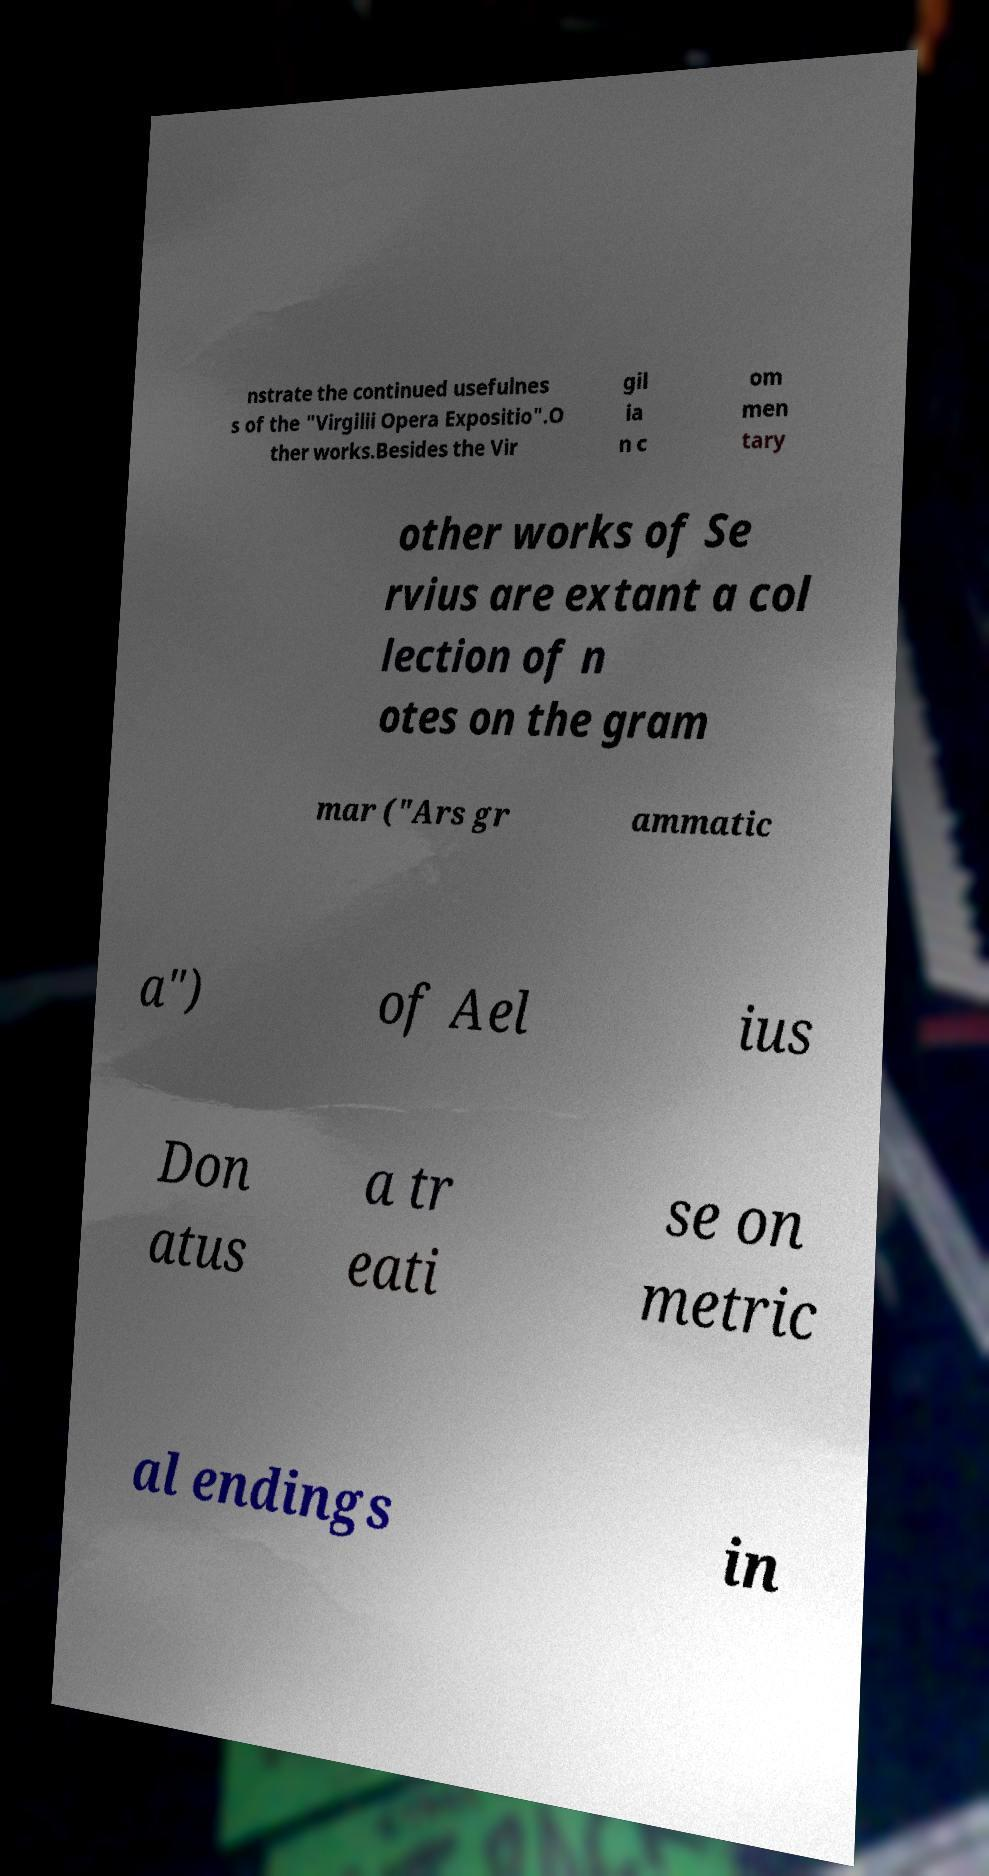Please identify and transcribe the text found in this image. nstrate the continued usefulnes s of the "Virgilii Opera Expositio".O ther works.Besides the Vir gil ia n c om men tary other works of Se rvius are extant a col lection of n otes on the gram mar ("Ars gr ammatic a") of Ael ius Don atus a tr eati se on metric al endings in 